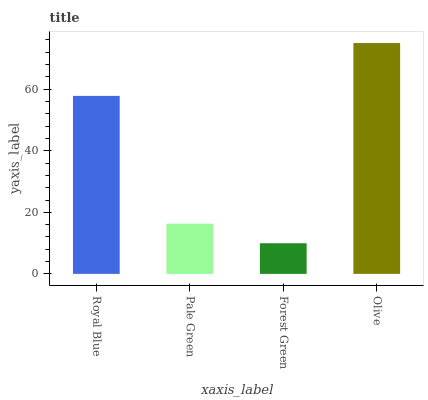Is Pale Green the minimum?
Answer yes or no. No. Is Pale Green the maximum?
Answer yes or no. No. Is Royal Blue greater than Pale Green?
Answer yes or no. Yes. Is Pale Green less than Royal Blue?
Answer yes or no. Yes. Is Pale Green greater than Royal Blue?
Answer yes or no. No. Is Royal Blue less than Pale Green?
Answer yes or no. No. Is Royal Blue the high median?
Answer yes or no. Yes. Is Pale Green the low median?
Answer yes or no. Yes. Is Pale Green the high median?
Answer yes or no. No. Is Olive the low median?
Answer yes or no. No. 